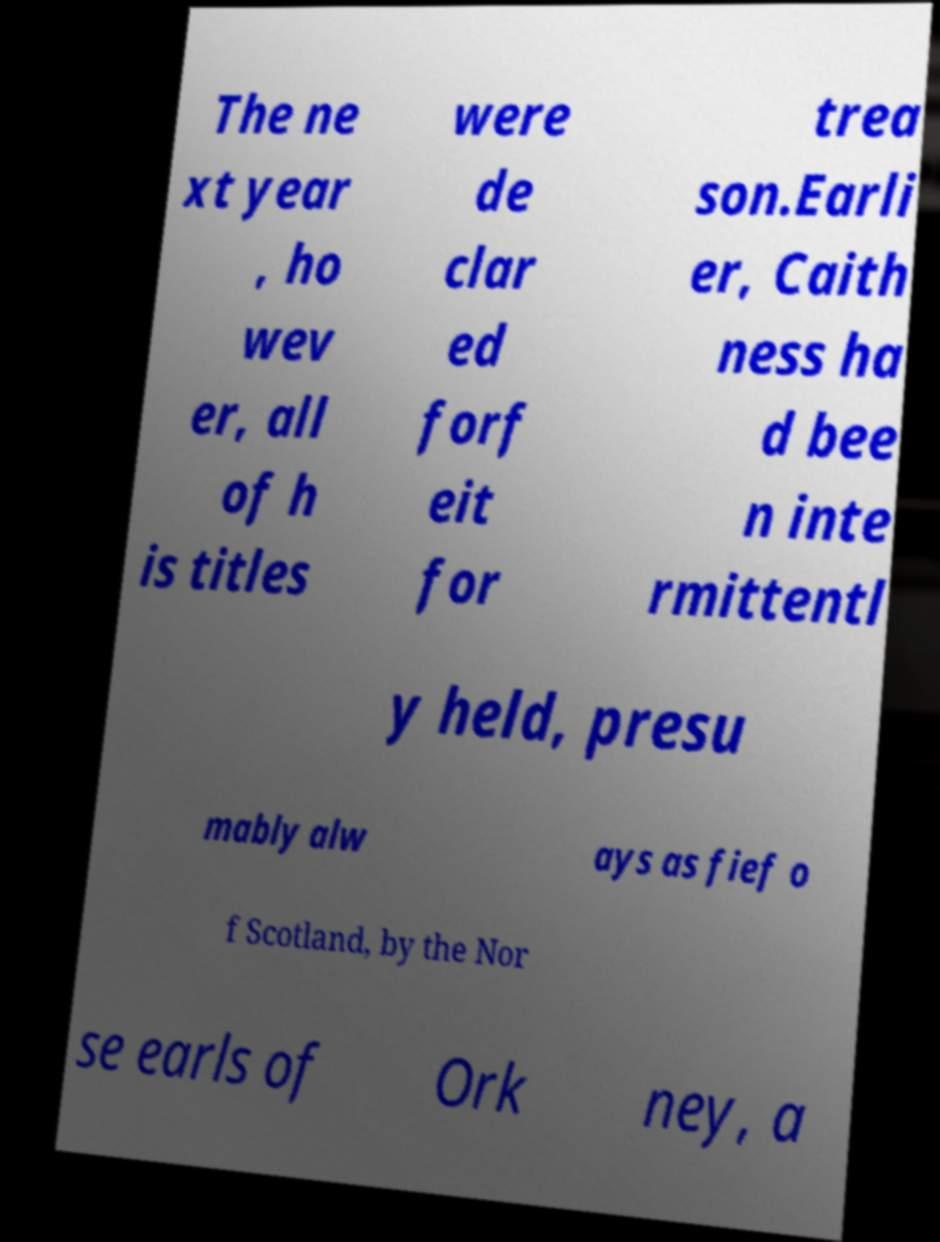Could you assist in decoding the text presented in this image and type it out clearly? The ne xt year , ho wev er, all of h is titles were de clar ed forf eit for trea son.Earli er, Caith ness ha d bee n inte rmittentl y held, presu mably alw ays as fief o f Scotland, by the Nor se earls of Ork ney, a 